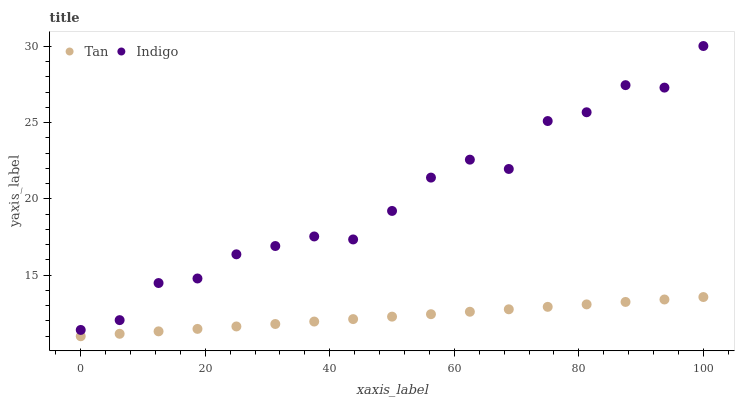Does Tan have the minimum area under the curve?
Answer yes or no. Yes. Does Indigo have the maximum area under the curve?
Answer yes or no. Yes. Does Indigo have the minimum area under the curve?
Answer yes or no. No. Is Tan the smoothest?
Answer yes or no. Yes. Is Indigo the roughest?
Answer yes or no. Yes. Is Indigo the smoothest?
Answer yes or no. No. Does Tan have the lowest value?
Answer yes or no. Yes. Does Indigo have the lowest value?
Answer yes or no. No. Does Indigo have the highest value?
Answer yes or no. Yes. Is Tan less than Indigo?
Answer yes or no. Yes. Is Indigo greater than Tan?
Answer yes or no. Yes. Does Tan intersect Indigo?
Answer yes or no. No. 